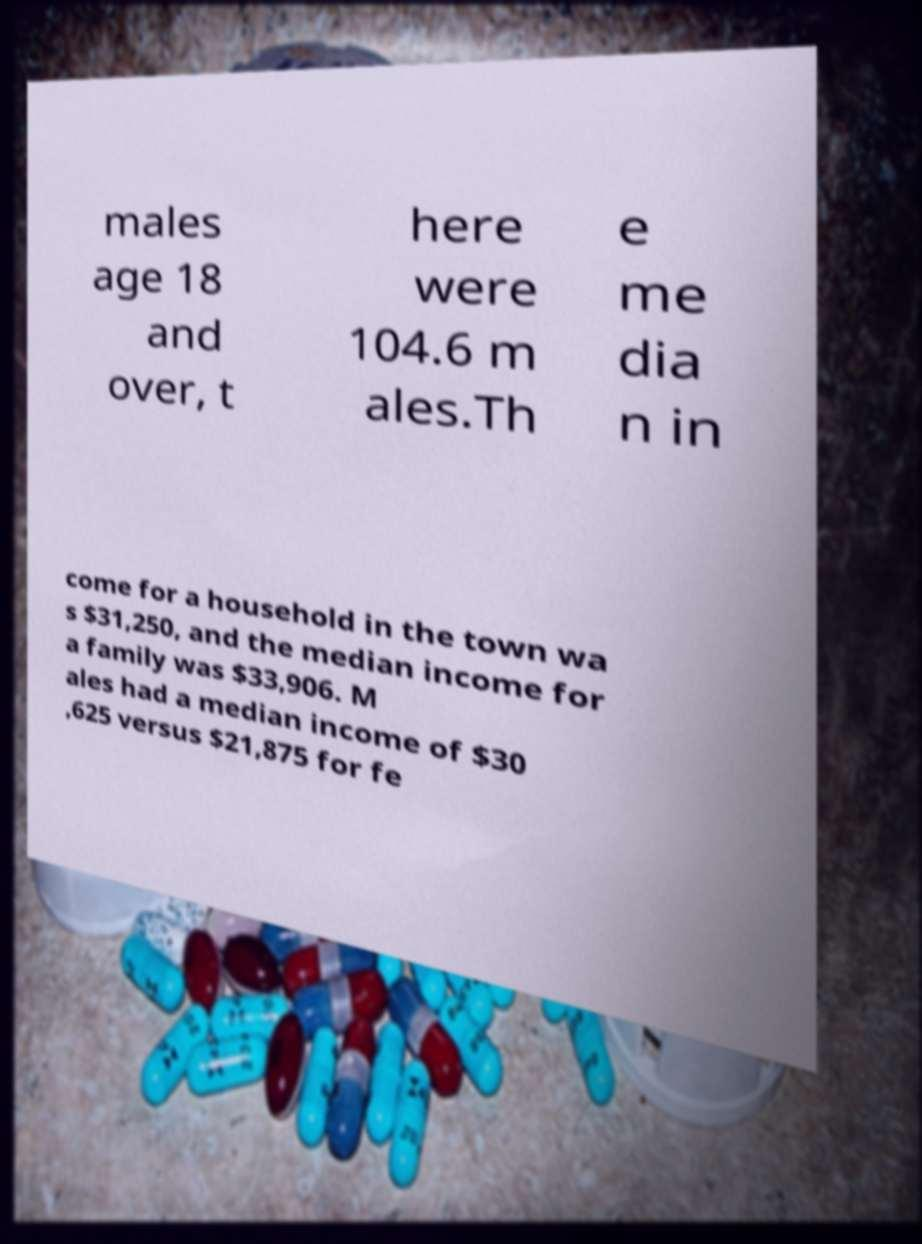Could you extract and type out the text from this image? males age 18 and over, t here were 104.6 m ales.Th e me dia n in come for a household in the town wa s $31,250, and the median income for a family was $33,906. M ales had a median income of $30 ,625 versus $21,875 for fe 